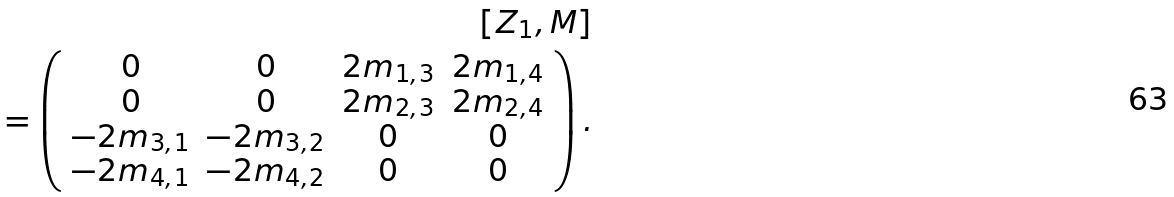<formula> <loc_0><loc_0><loc_500><loc_500>\left [ Z _ { 1 } , M \right ] \\ = \left ( \begin{array} { c c c c } 0 & 0 & 2 m _ { 1 , 3 } & 2 m _ { 1 , 4 } \\ 0 & 0 & 2 m _ { 2 , 3 } & 2 m _ { 2 , 4 } \\ - 2 m _ { 3 , 1 } & - 2 m _ { 3 , 2 } & 0 & 0 \\ - 2 m _ { 4 , 1 } & - 2 m _ { 4 , 2 } & 0 & 0 \end{array} \right ) .</formula> 